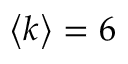<formula> <loc_0><loc_0><loc_500><loc_500>\left < k \right > = 6</formula> 